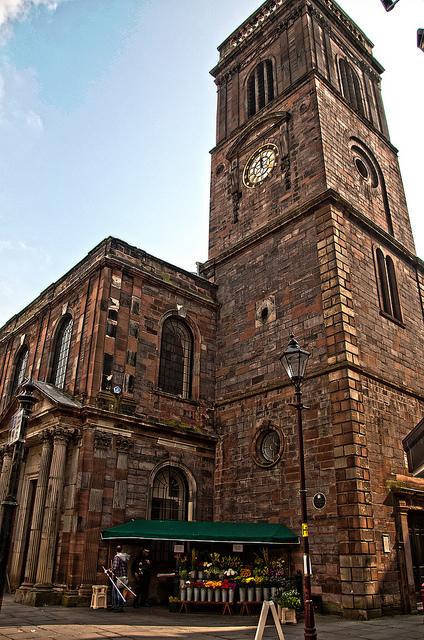What are they selling in the picture?
Concise answer only. Flowers. What color is the tent?
Write a very short answer. Green. What material is the building made out of?
Short answer required. Brick. 